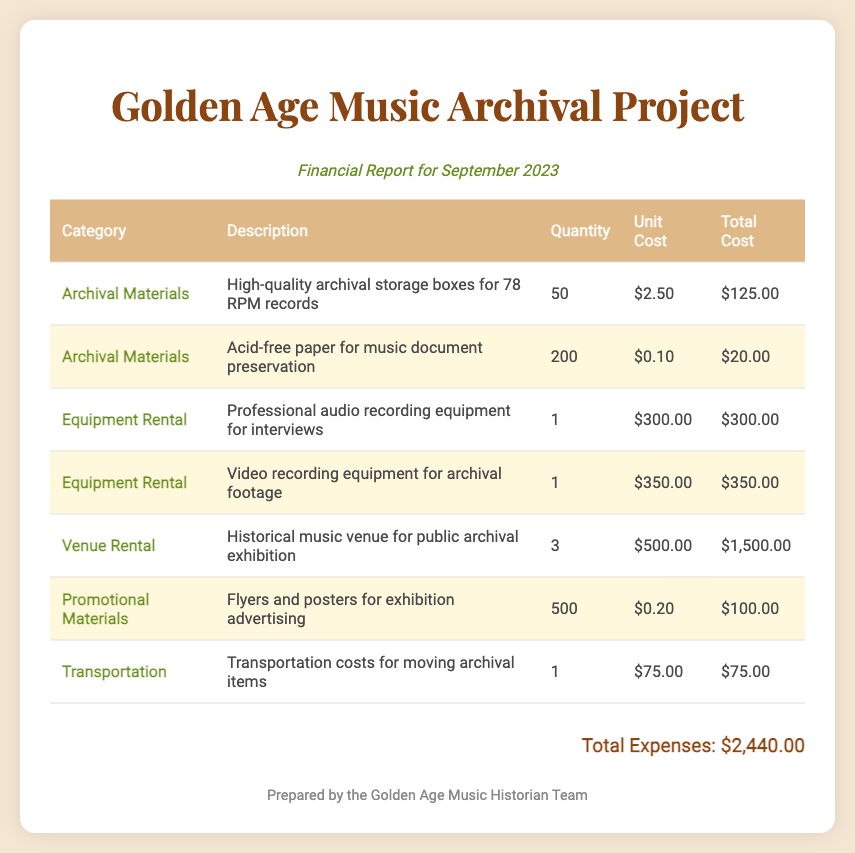what is the total cost for archival materials? The total cost for archival materials can be found by adding the costs listed under this category, which are $125.00 and $20.00, totaling $145.00.
Answer: $145.00 how many professional audio recording equipment items were rented? The document states that there was one professional audio recording equipment rented.
Answer: 1 what is the unit cost for acid-free paper? The unit cost for acid-free paper is stated in the document as $0.10.
Answer: $0.10 what is the total cost for venue rentals? The total cost for venue rentals is calculated by multiplying the quantity (3) by the unit cost ($500.00), which gives $1,500.00.
Answer: $1,500.00 how many quantities of flyers and posters were produced? The document specifies that 500 flyers and posters were produced for exhibition advertising.
Answer: 500 what is the total expenses amount reported? The total expenses amount is mentioned at the bottom of the report as $2,440.00.
Answer: $2,440.00 which category has the highest total cost? The category with the highest total cost is venue rental, totaling $1,500.00.
Answer: Venue Rental how many items were transported? The document indicates that only one transportation cost for moving archival items is listed.
Answer: 1 